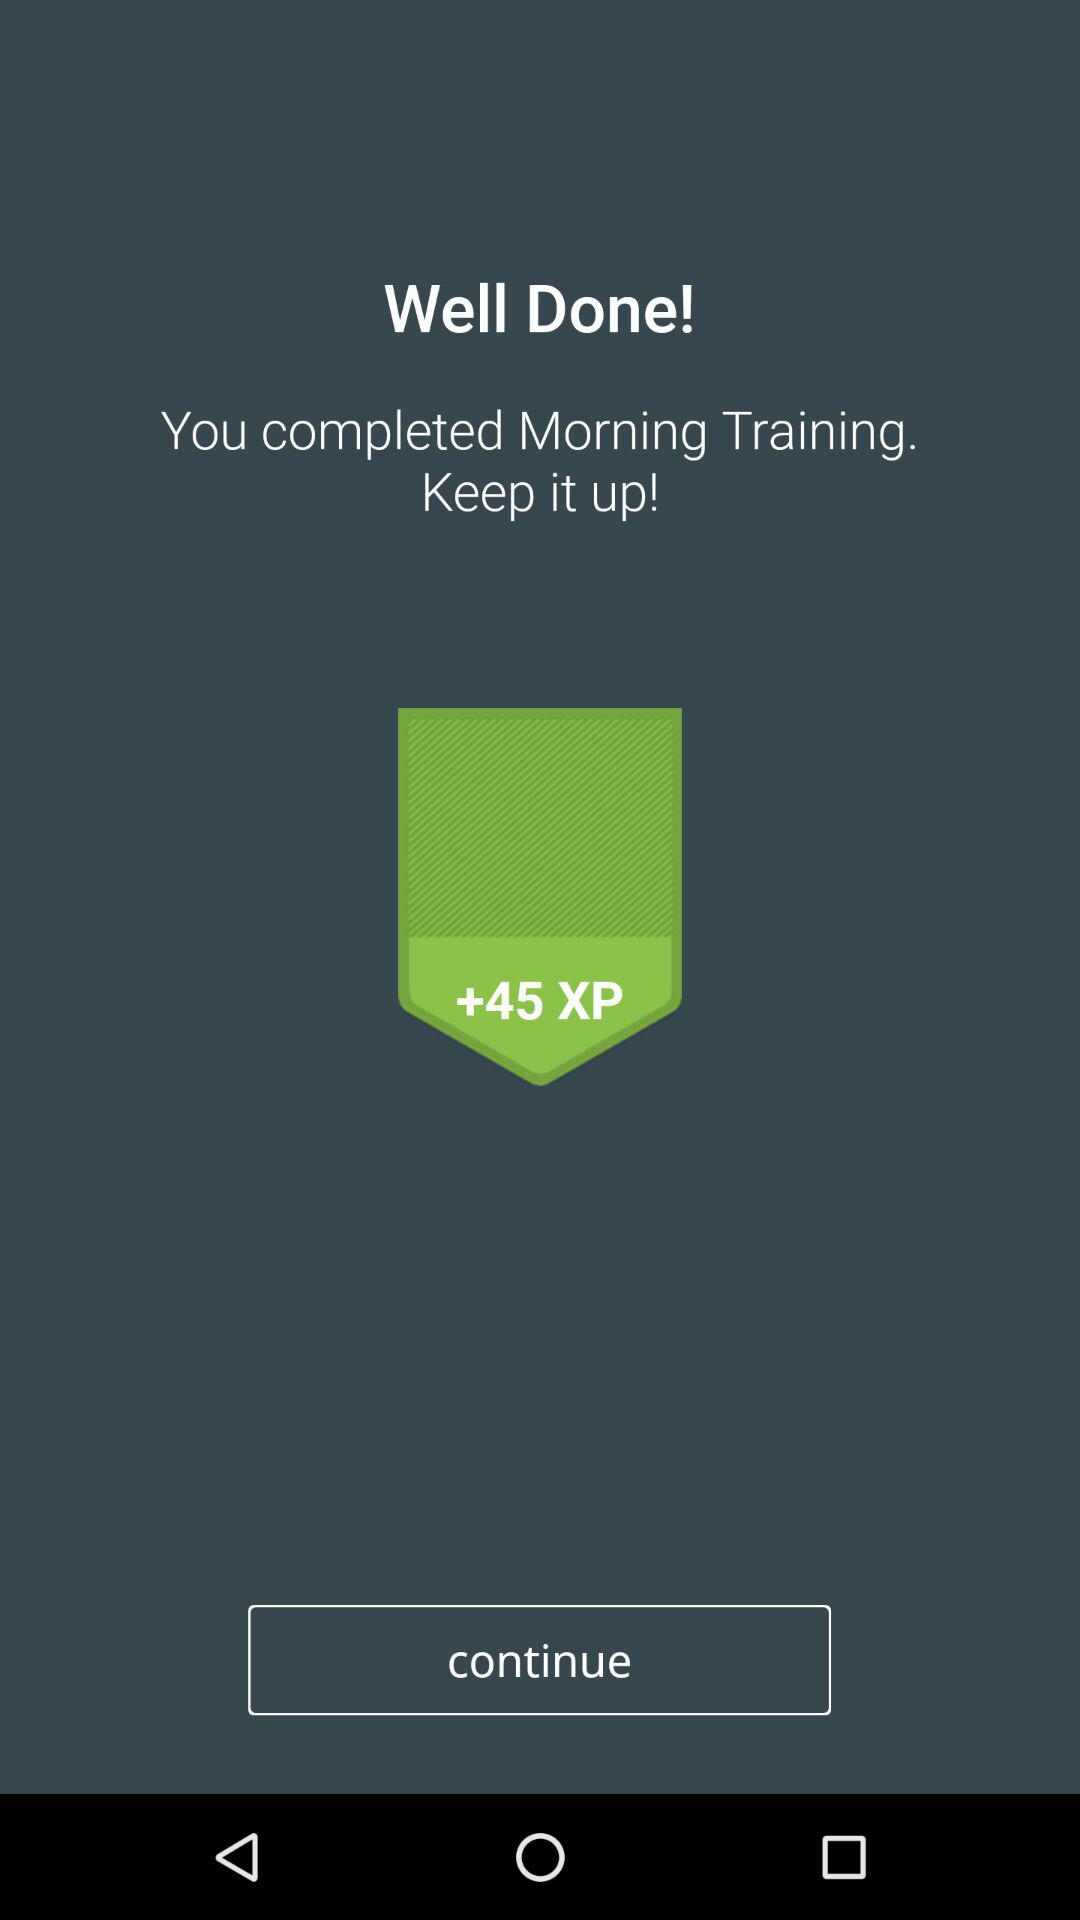How many XP points are rewarded for completing the Morning Training session?
Answer the question using a single word or phrase. 45 